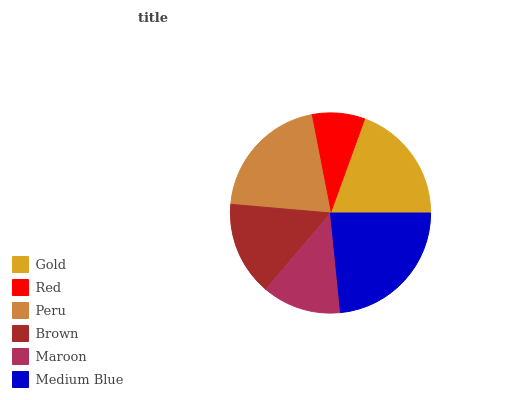Is Red the minimum?
Answer yes or no. Yes. Is Medium Blue the maximum?
Answer yes or no. Yes. Is Peru the minimum?
Answer yes or no. No. Is Peru the maximum?
Answer yes or no. No. Is Peru greater than Red?
Answer yes or no. Yes. Is Red less than Peru?
Answer yes or no. Yes. Is Red greater than Peru?
Answer yes or no. No. Is Peru less than Red?
Answer yes or no. No. Is Gold the high median?
Answer yes or no. Yes. Is Brown the low median?
Answer yes or no. Yes. Is Medium Blue the high median?
Answer yes or no. No. Is Medium Blue the low median?
Answer yes or no. No. 